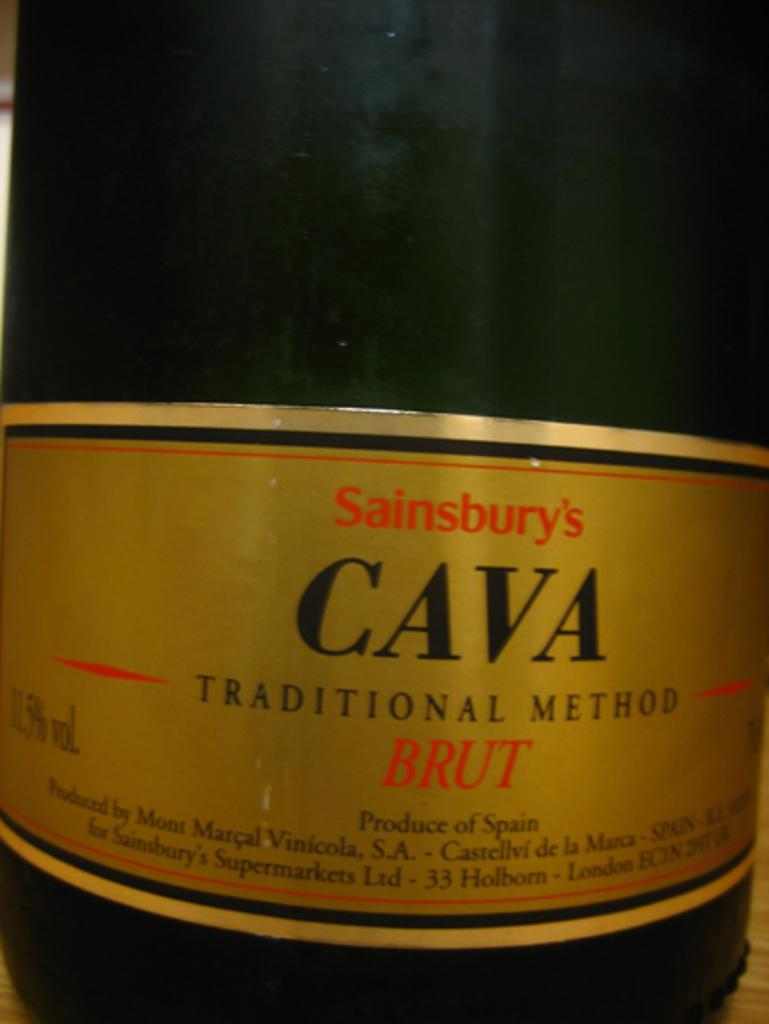<image>
Describe the image concisely. Bottle of alcohol with the word "Sainsbury" in red. 